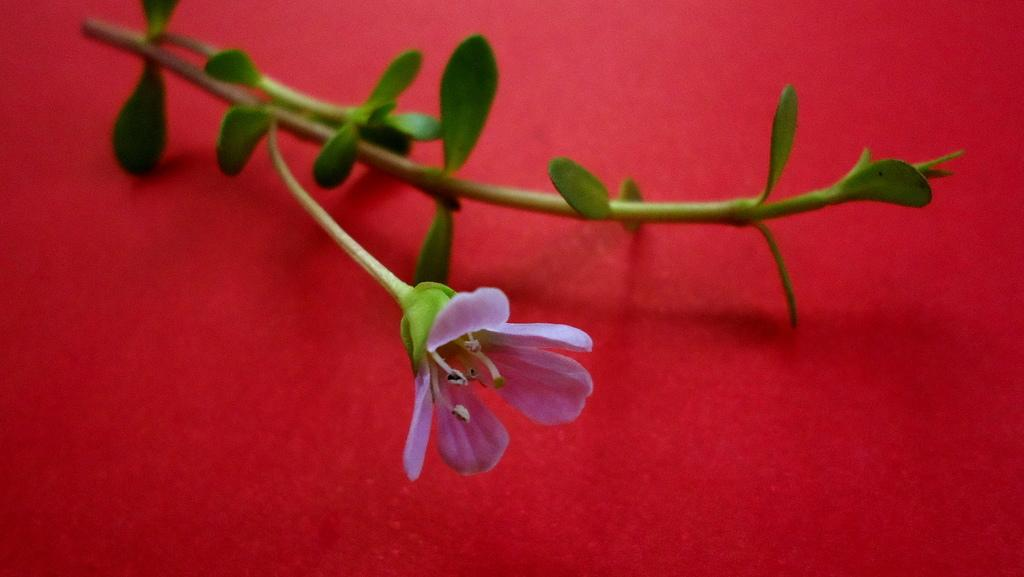What is the color of the surface in the image? The surface in the image is red. What is attached to the red surface? There is a stem with green leaves in the image. What type of flower is present on the stem? There is a purple colored flower on the stem. Can you hear the band playing in the image? There is no band present in the image, so it is not possible to hear any music. 